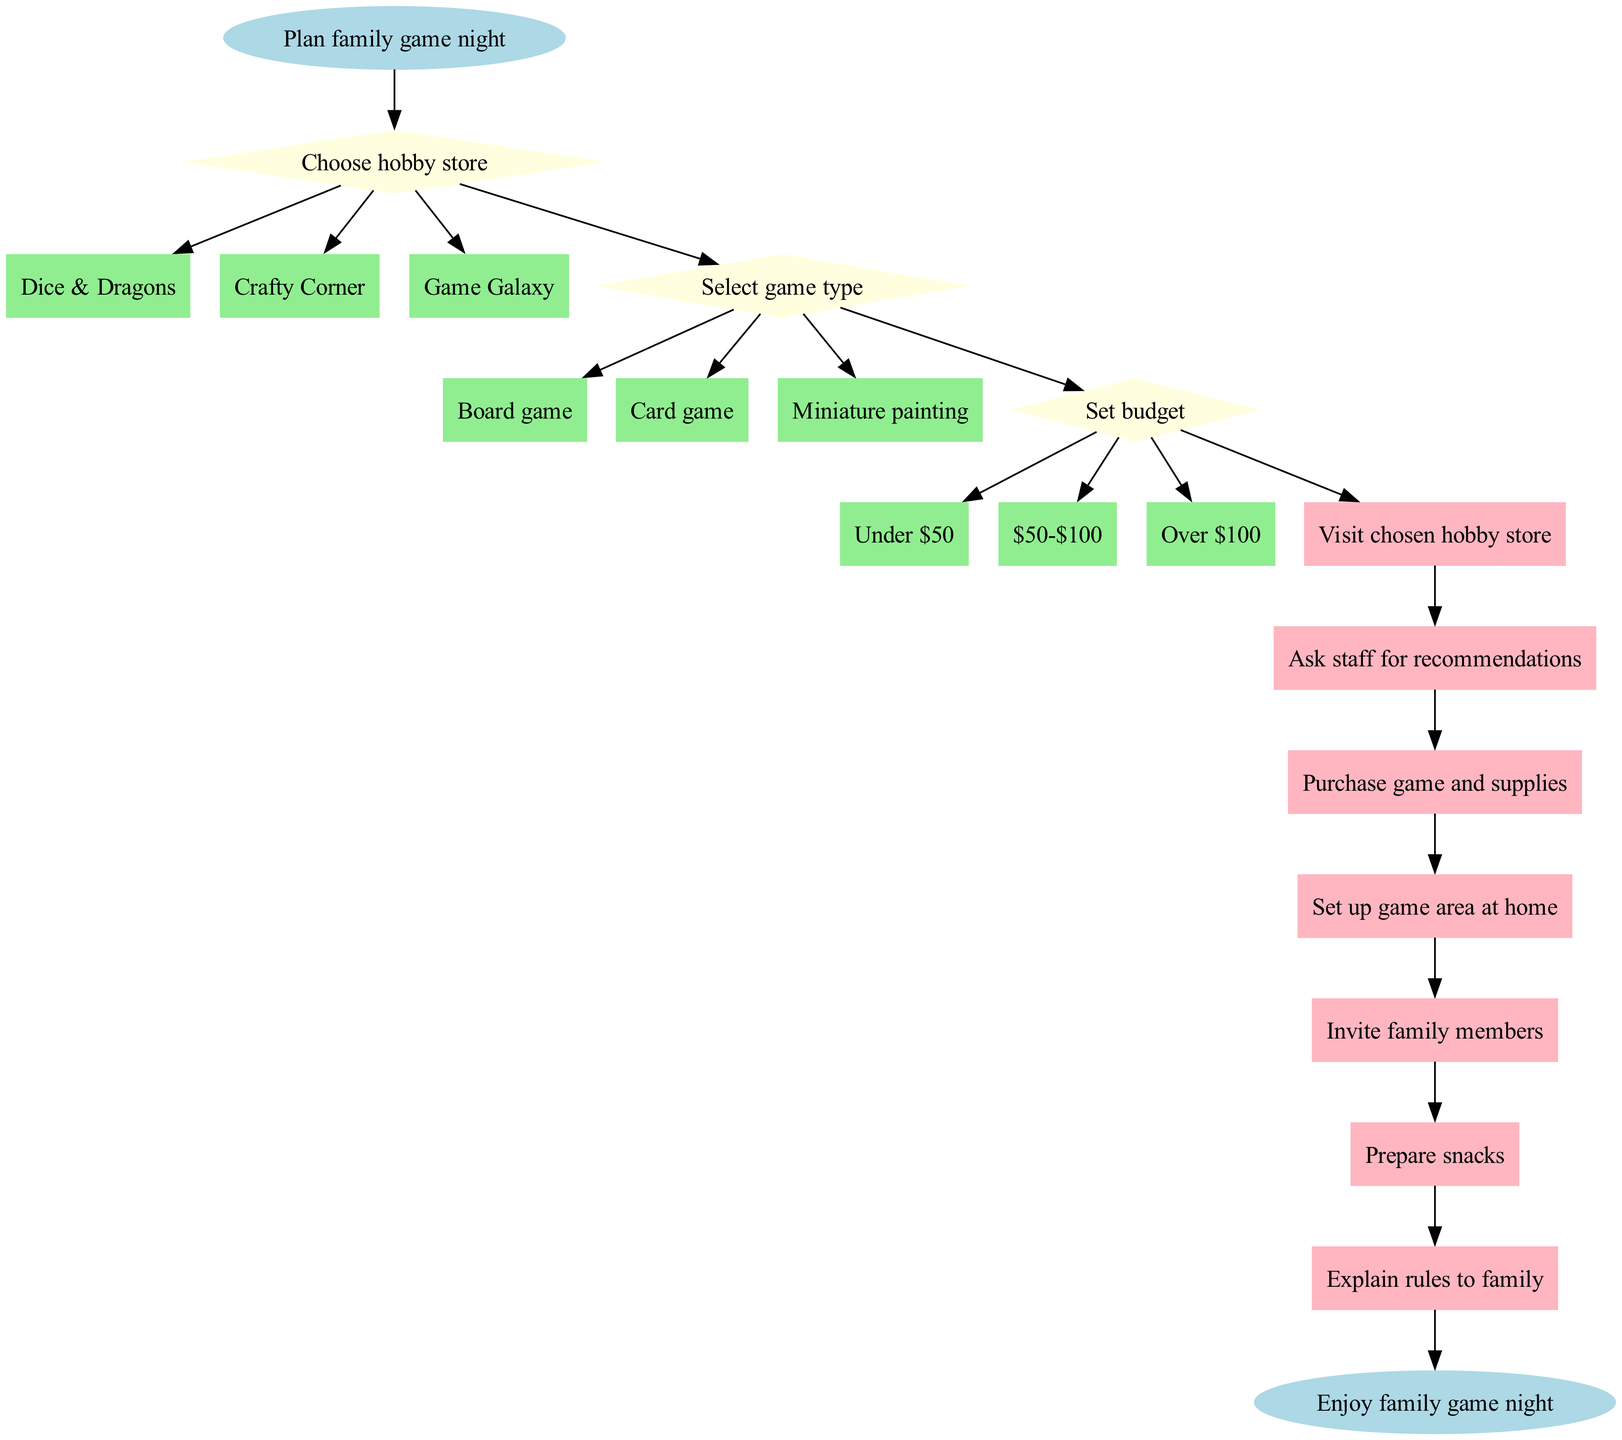What is the starting point of the flowchart? The starting point identified in the flowchart is "Plan family game night," which serves as the initial action to be taken.
Answer: Plan family game night How many decision points are there in the flowchart? The flowchart contains three decision points: choosing a hobby store, selecting game type, and setting a budget.
Answer: 3 What are the options under the decision "Select game type"? The options provided under this decision are "Board game," "Card game," and "Miniature painting," which represent the different game types one can choose from.
Answer: Board game, Card game, Miniature painting After selecting a game, what is the next action in the flowchart? Following the selection of a game, the next action listed is "Visit chosen hobby store," indicating that one must go to the store to obtain supplies.
Answer: Visit chosen hobby store Which action directly follows "Prepare snacks"? The action that follows "Prepare snacks" is "Explain rules to family," as this indicates the sequence of activities in preparing for the game night.
Answer: Explain rules to family If deciding on a budget, what are the options available? The available budget options mentioned in the flowchart are "Under $50," "$50-$100," and "Over $100," providing clear financial ranges for planning.
Answer: Under $50, $50-$100, Over $100 Which hobby store appears first in the flowchart? The first hobby store mentioned in the flowchart is "Dice & Dragons," which is listed as the first option when choosing a hobby store.
Answer: Dice & Dragons What is the end point of the flowchart? The flowchart concludes with the endpoint labeled "Enjoy family game night," summarizing the final outcome of all preceding actions and decisions.
Answer: Enjoy family game night 